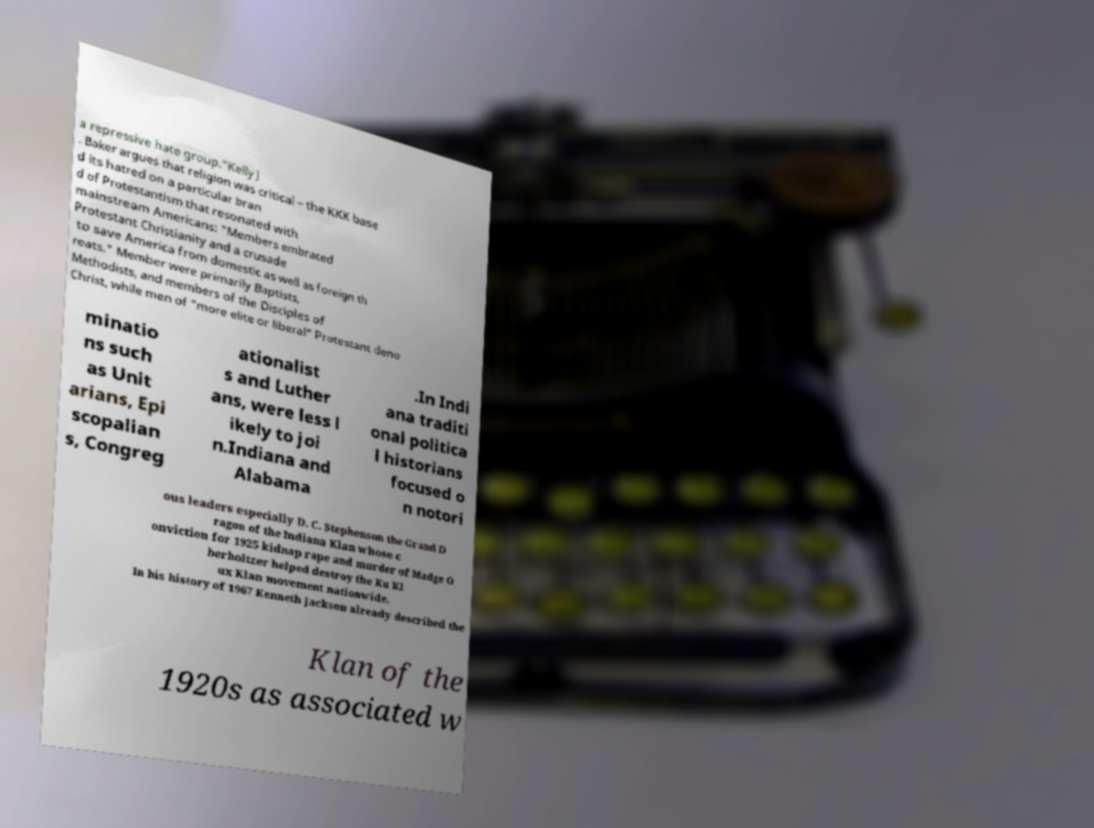Could you extract and type out the text from this image? a repressive hate group."Kelly J . Baker argues that religion was critical – the KKK base d its hatred on a particular bran d of Protestantism that resonated with mainstream Americans: "Members embraced Protestant Christianity and a crusade to save America from domestic as well as foreign th reats." Member were primarily Baptists, Methodists, and members of the Disciples of Christ, while men of "more elite or liberal" Protestant deno minatio ns such as Unit arians, Epi scopalian s, Congreg ationalist s and Luther ans, were less l ikely to joi n.Indiana and Alabama .In Indi ana traditi onal politica l historians focused o n notori ous leaders especially D. C. Stephenson the Grand D ragon of the Indiana Klan whose c onviction for 1925 kidnap rape and murder of Madge O berholtzer helped destroy the Ku Kl ux Klan movement nationwide. In his history of 1967 Kenneth Jackson already described the Klan of the 1920s as associated w 